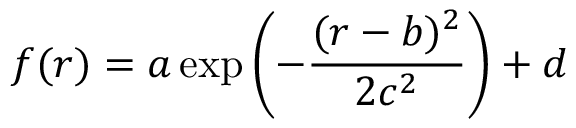Convert formula to latex. <formula><loc_0><loc_0><loc_500><loc_500>f ( r ) = a \exp \left ( - \frac { ( r - b ) ^ { 2 } } { 2 c ^ { 2 } } \right ) + d</formula> 